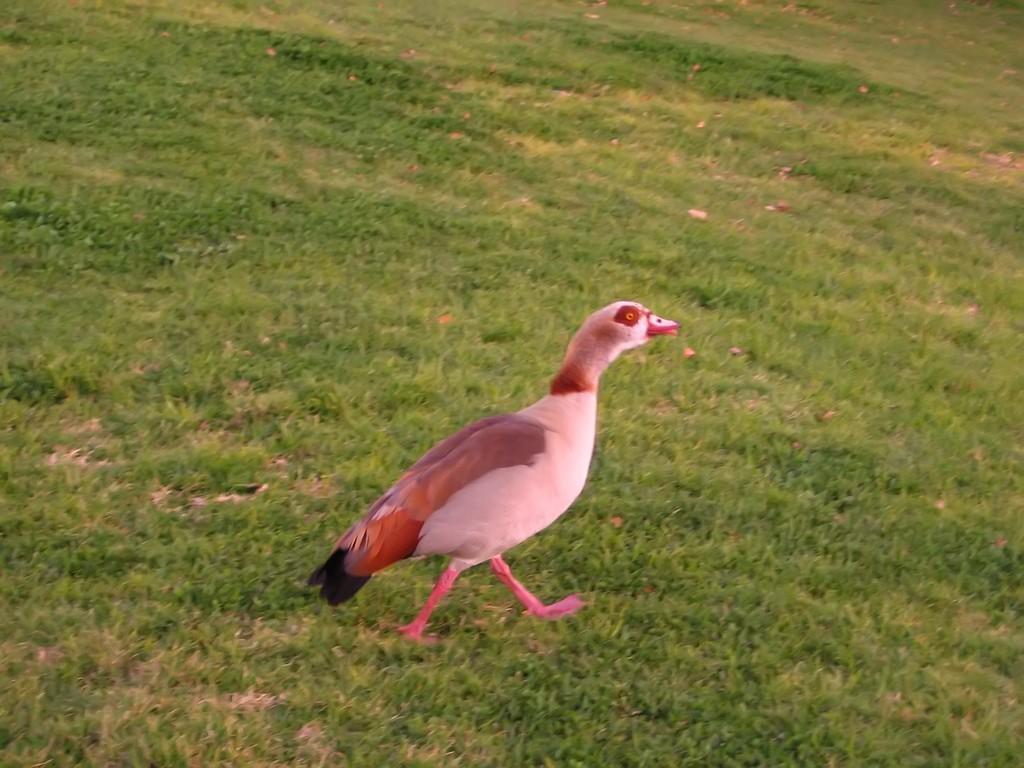Please provide a concise description of this image. In the front of the image I can see a bird. Land is covered with grass. 